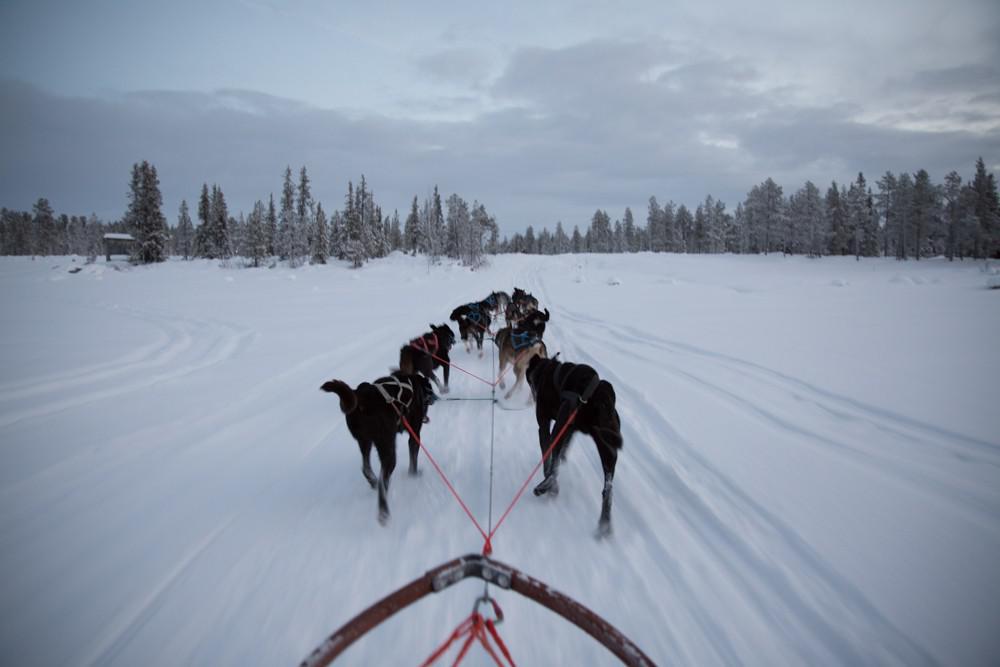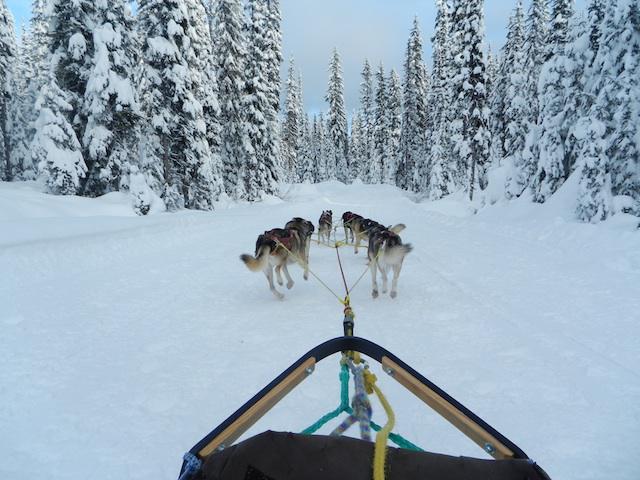The first image is the image on the left, the second image is the image on the right. For the images shown, is this caption "There are trees lining the trail in the image on the right" true? Answer yes or no. Yes. 